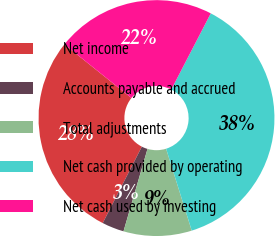Convert chart to OTSL. <chart><loc_0><loc_0><loc_500><loc_500><pie_chart><fcel>Net income<fcel>Accounts payable and accrued<fcel>Total adjustments<fcel>Net cash provided by operating<fcel>Net cash used by investing<nl><fcel>28.21%<fcel>3.02%<fcel>9.34%<fcel>37.56%<fcel>21.87%<nl></chart> 